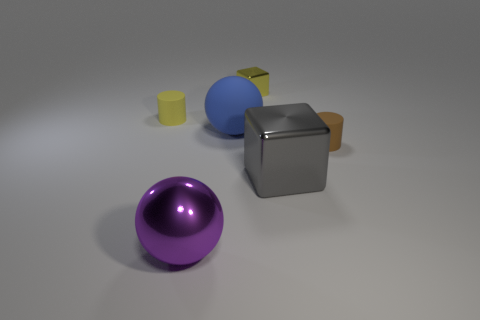Do the small metallic thing and the big block have the same color?
Offer a terse response. No. What number of other things are the same color as the metallic sphere?
Your answer should be compact. 0. What shape is the small thing in front of the cylinder behind the blue sphere?
Ensure brevity in your answer.  Cylinder. There is a tiny cube; how many big metallic objects are to the left of it?
Make the answer very short. 1. Are there any yellow blocks made of the same material as the gray block?
Provide a short and direct response. Yes. What material is the block that is the same size as the yellow rubber thing?
Give a very brief answer. Metal. There is a rubber thing that is both on the left side of the brown rubber thing and on the right side of the big purple metallic ball; what size is it?
Your answer should be very brief. Large. There is a small object that is both to the right of the blue sphere and behind the tiny brown matte cylinder; what color is it?
Ensure brevity in your answer.  Yellow. Are there fewer cubes that are to the left of the big gray thing than blocks that are in front of the purple thing?
Make the answer very short. No. How many blue matte things are the same shape as the tiny yellow metal object?
Give a very brief answer. 0. 